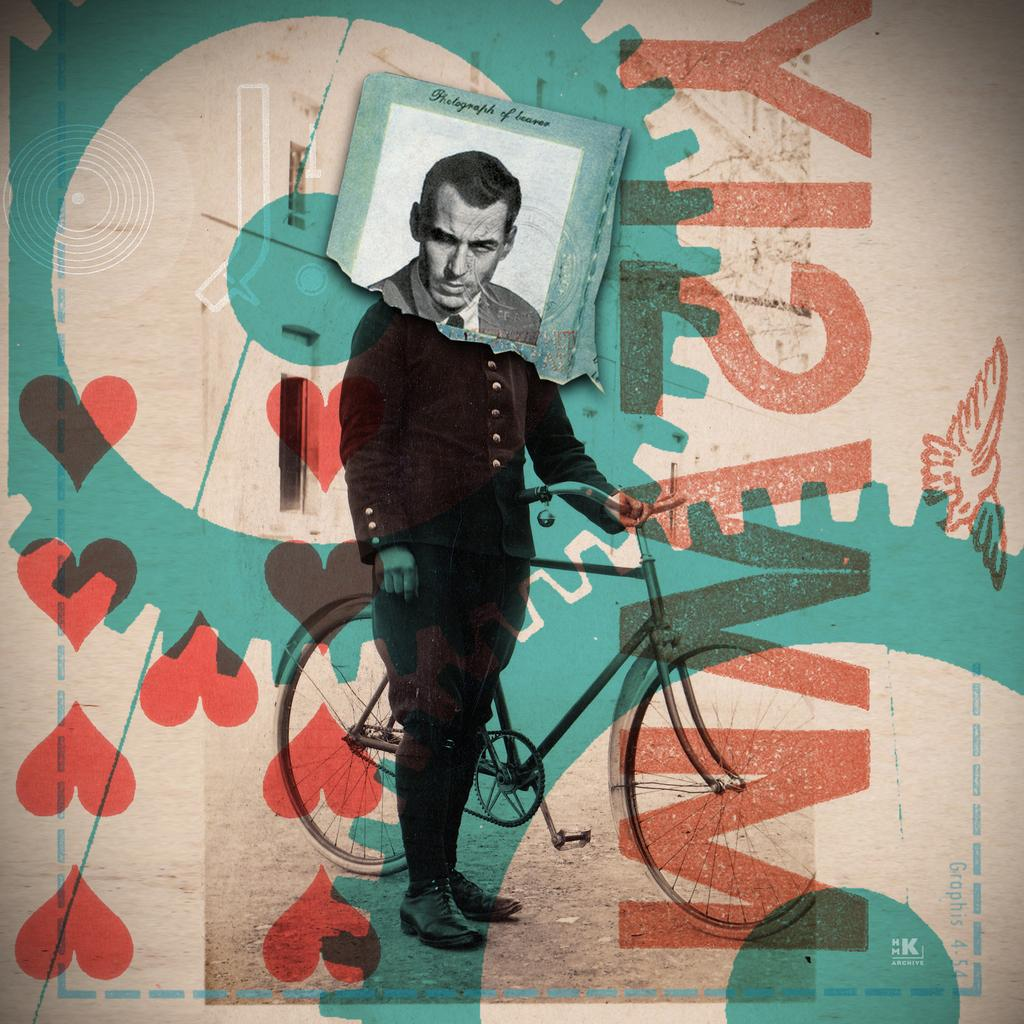What is depicted on the poster in the image? The poster features a man in the image. Can you describe the man's appearance? The man is wearing a black coat. What is the man holding in the image? The man is holding a bicycle. Are there any additional elements on the poster? Yes, there is a small photograph stick on the poster. What type of tooth can be seen in the image? There is no tooth present in the image; it features a poster with a man holding a bicycle. Is there a ring visible on the man's finger in the image? There is no ring visible on the man's finger in the image; he is wearing a black coat and holding a bicycle. 